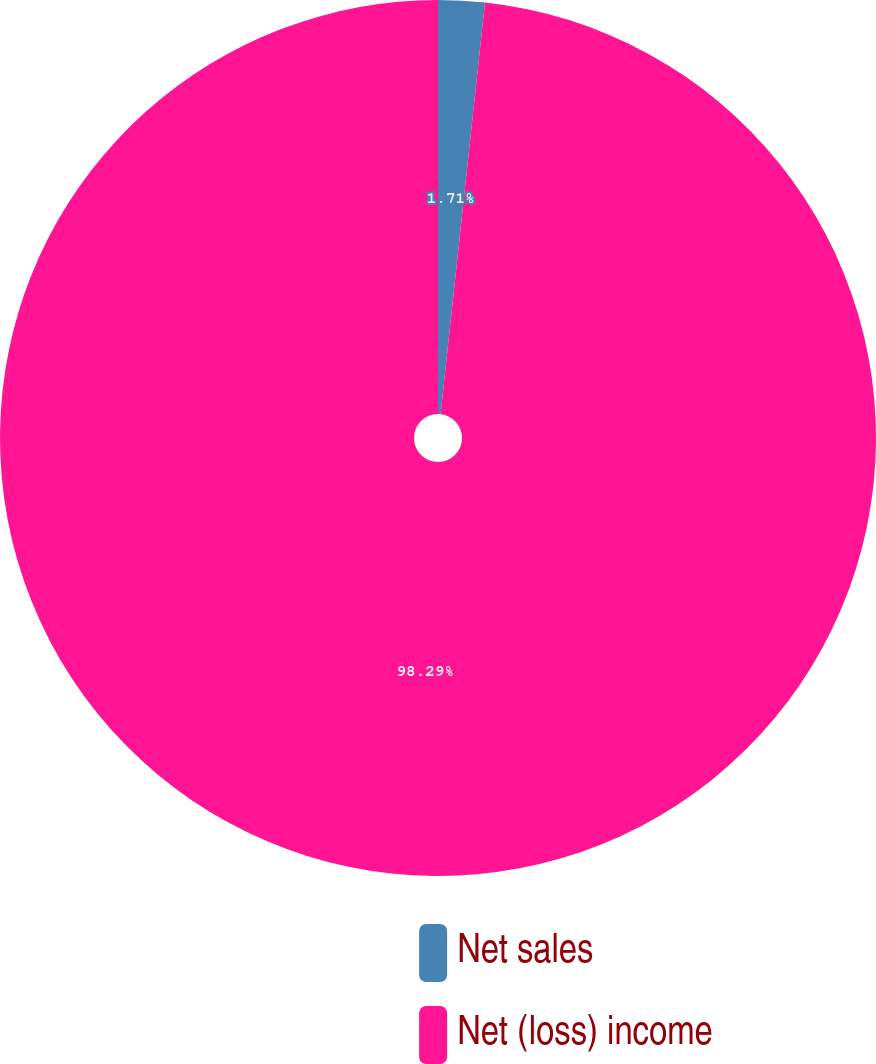<chart> <loc_0><loc_0><loc_500><loc_500><pie_chart><fcel>Net sales<fcel>Net (loss) income<nl><fcel>1.71%<fcel>98.29%<nl></chart> 